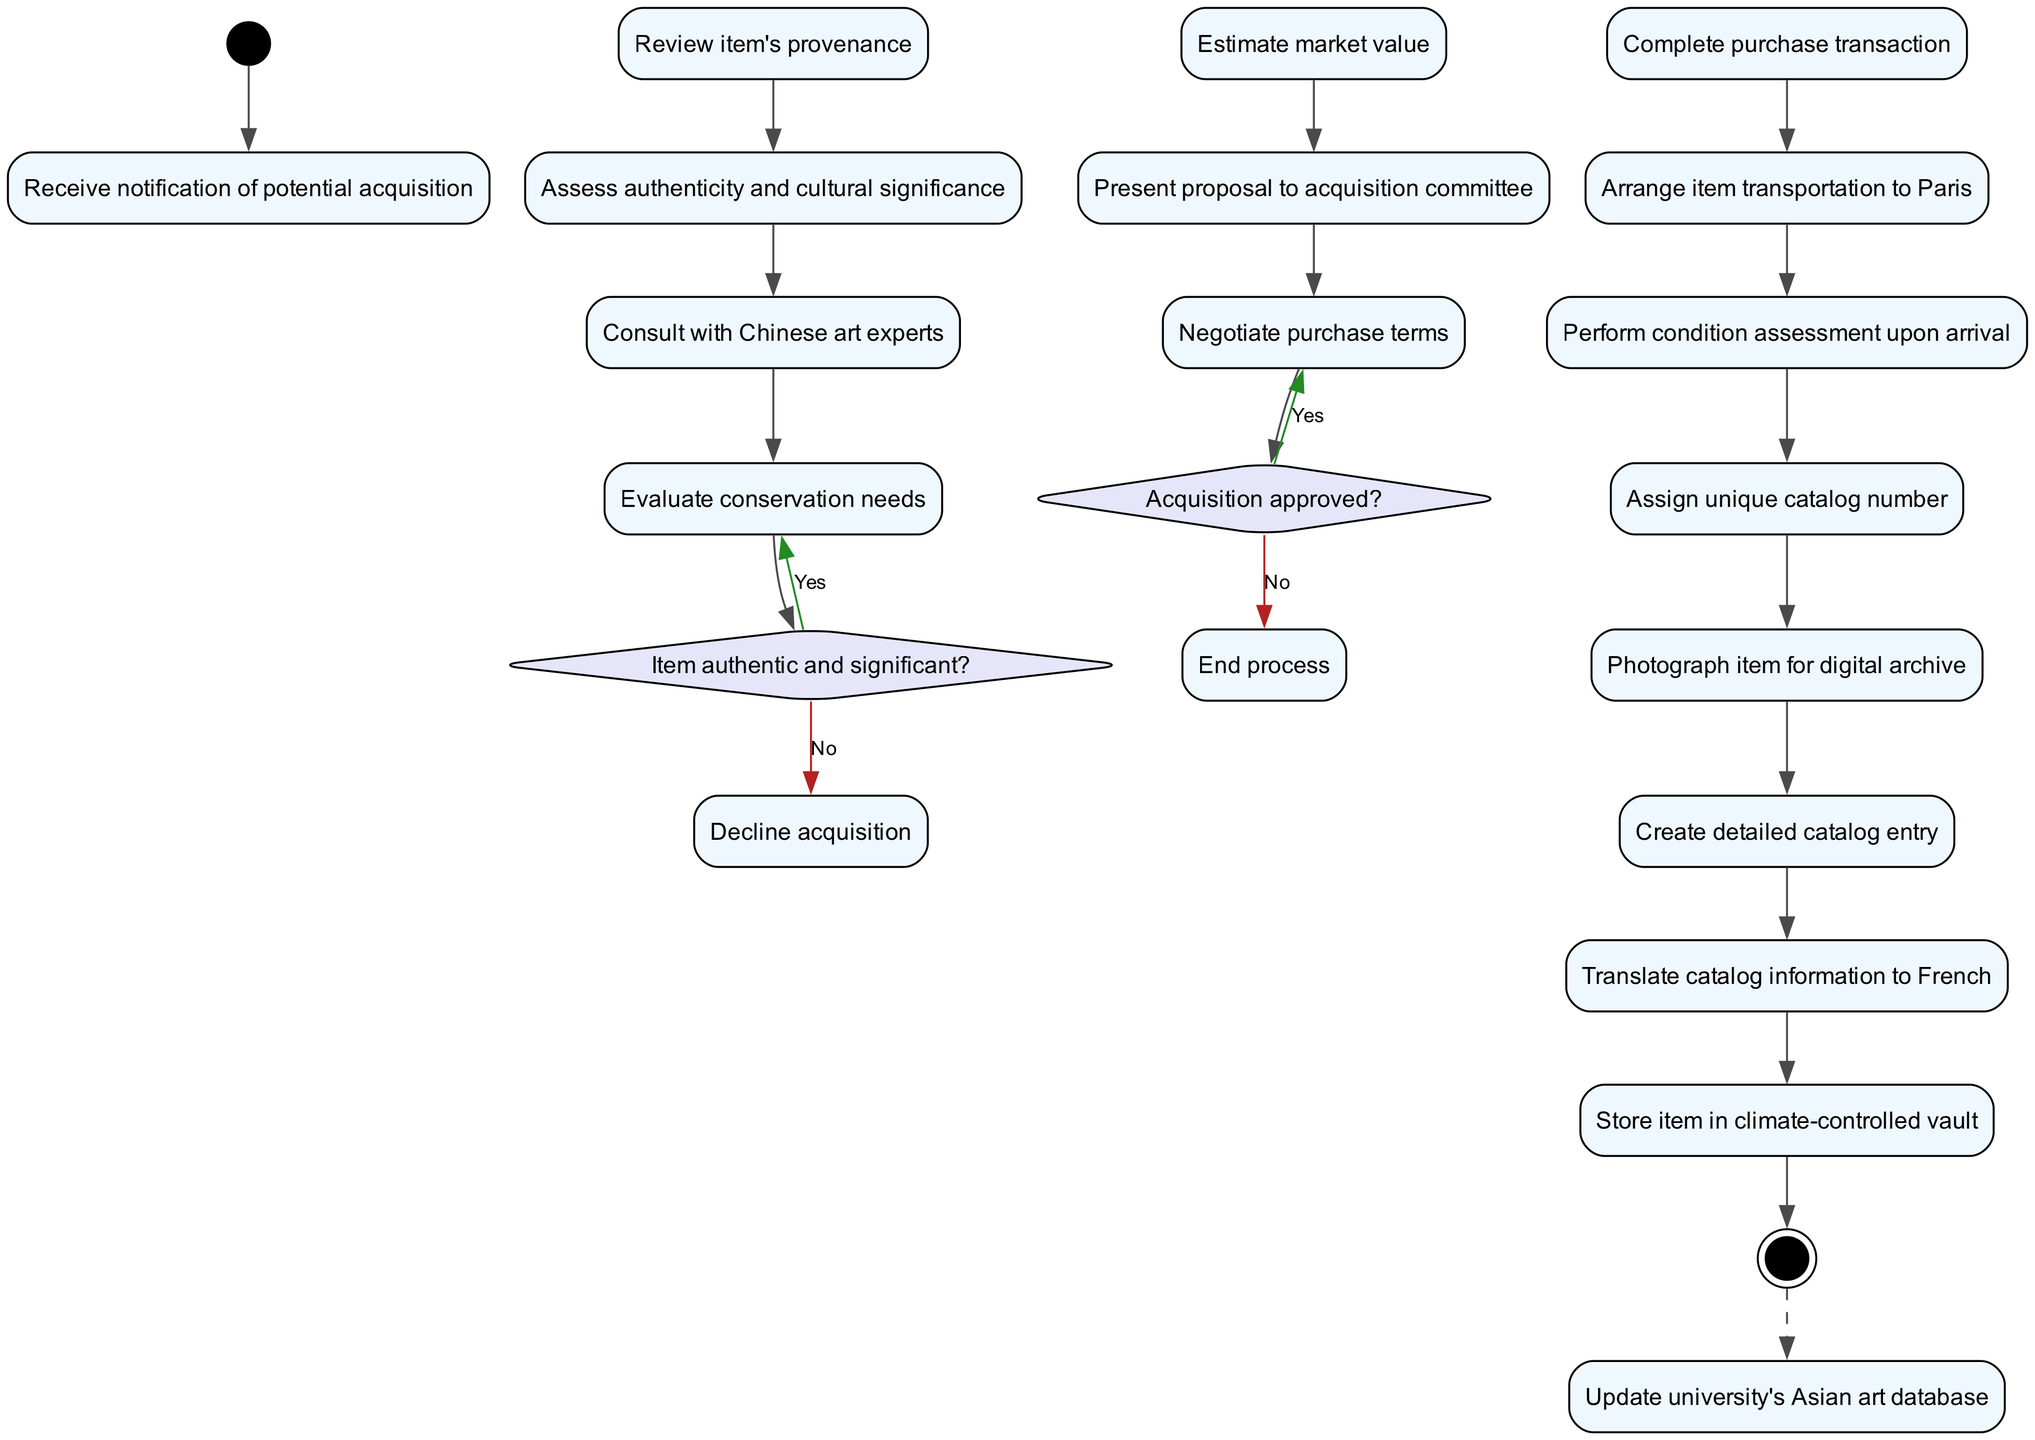what is the starting node of the diagram? The starting node is labeled as "Receive notification of potential acquisition". This is identified by following the arrow from the black circle denoting the start of the diagram.
Answer: Receive notification of potential acquisition how many total activities are outlined in the diagram? By counting the nodes labeled with activities, there are a total of 13 activities represented in the diagram.
Answer: 13 what decision follows the assessment of authenticity and cultural significance? The decision that follows is titled "Item authentic and significant?", where a 'Yes' leads to "Evaluate conservation needs" and a 'No' leads to "Decline acquisition". This is derived from analyzing the flow immediately after the corresponding activity.
Answer: Item authentic and significant? what is the next step if the acquisition is approved? If the acquisition is approved, the next step is "Negotiate purchase terms". This follows directly from the decision node regarding acquisition approval.
Answer: Negotiate purchase terms how many decision nodes are present in the diagram? There are 2 decision nodes present in the diagram, which are: "Item authentic and significant?" and "Acquisition approved?". This can be verified by counting the diamond-shaped nodes in the diagram.
Answer: 2 what happens after "Perform condition assessment upon arrival"? The next activity after "Perform condition assessment upon arrival" is "Assign unique catalog number". This can be traced in the flow of activities following condition assessment.
Answer: Assign unique catalog number is the final node a process or a decision? The final node is not a decision; it is a process labeled "Update university's Asian art database". This is evident as it appears at the end and has a dashed edge connecting to it.
Answer: Process which activity would be skipped if the acquisition is not approved? If the acquisition is not approved, the activity "Negotiate purchase terms" would be skipped as the flow terminates at the decision node. This can be inferred from the 'No' path following the approval decision.
Answer: Negotiate purchase terms what color indicates the decision nodes in the diagram? The decision nodes are colored in a light shade of purple, specifically referred to as '#E6E6FA' in the diagram’s formatting attributes.
Answer: Light purple 